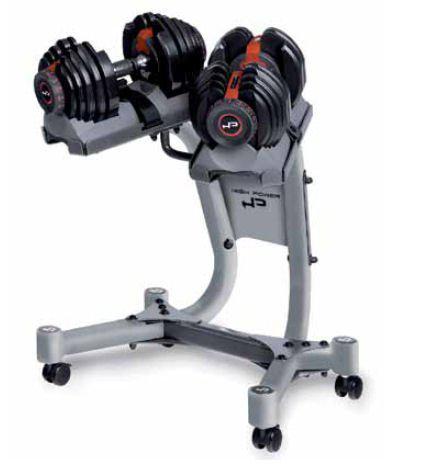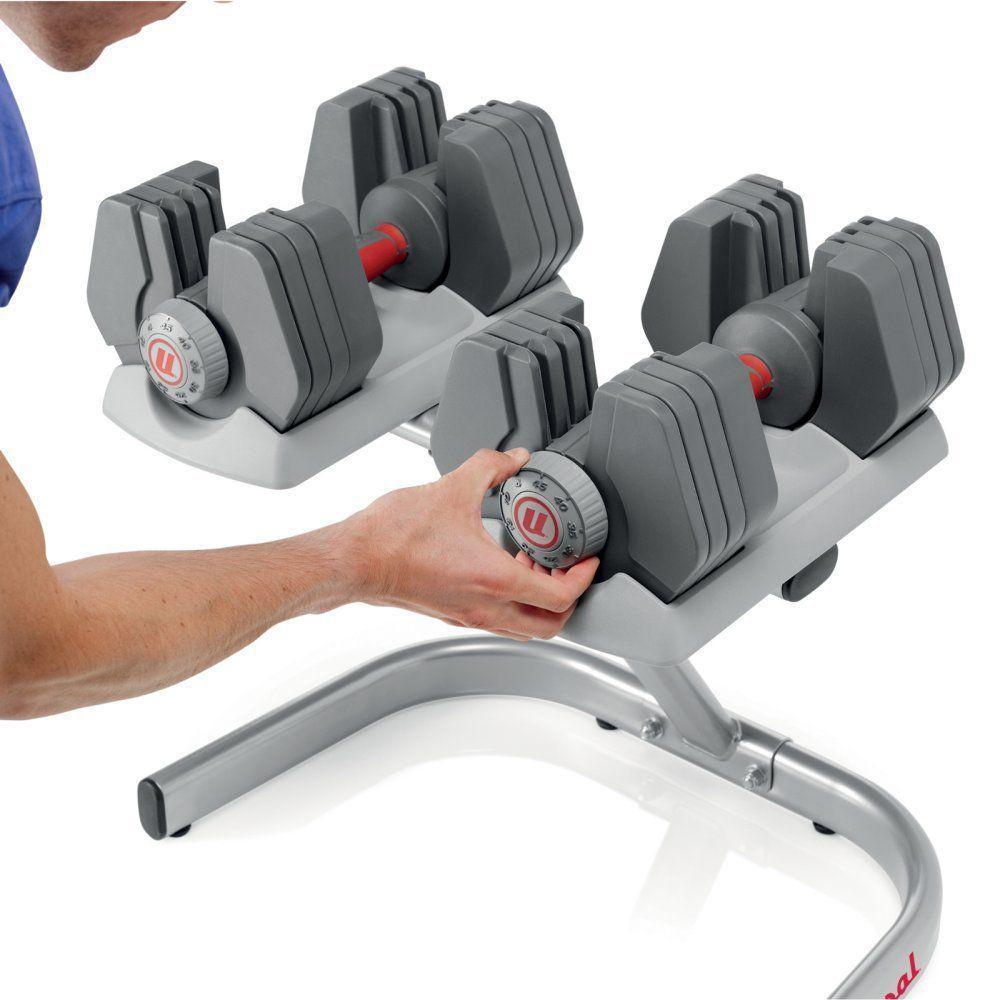The first image is the image on the left, the second image is the image on the right. Evaluate the accuracy of this statement regarding the images: "A person is touching the dumbbells in the right image only.". Is it true? Answer yes or no. Yes. The first image is the image on the left, the second image is the image on the right. Given the left and right images, does the statement "A person is interacting with the weights in the image on the right." hold true? Answer yes or no. Yes. 